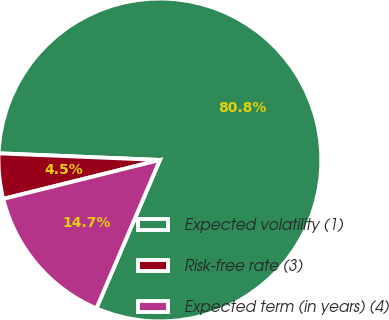Convert chart. <chart><loc_0><loc_0><loc_500><loc_500><pie_chart><fcel>Expected volatility (1)<fcel>Risk-free rate (3)<fcel>Expected term (in years) (4)<nl><fcel>80.78%<fcel>4.53%<fcel>14.69%<nl></chart> 